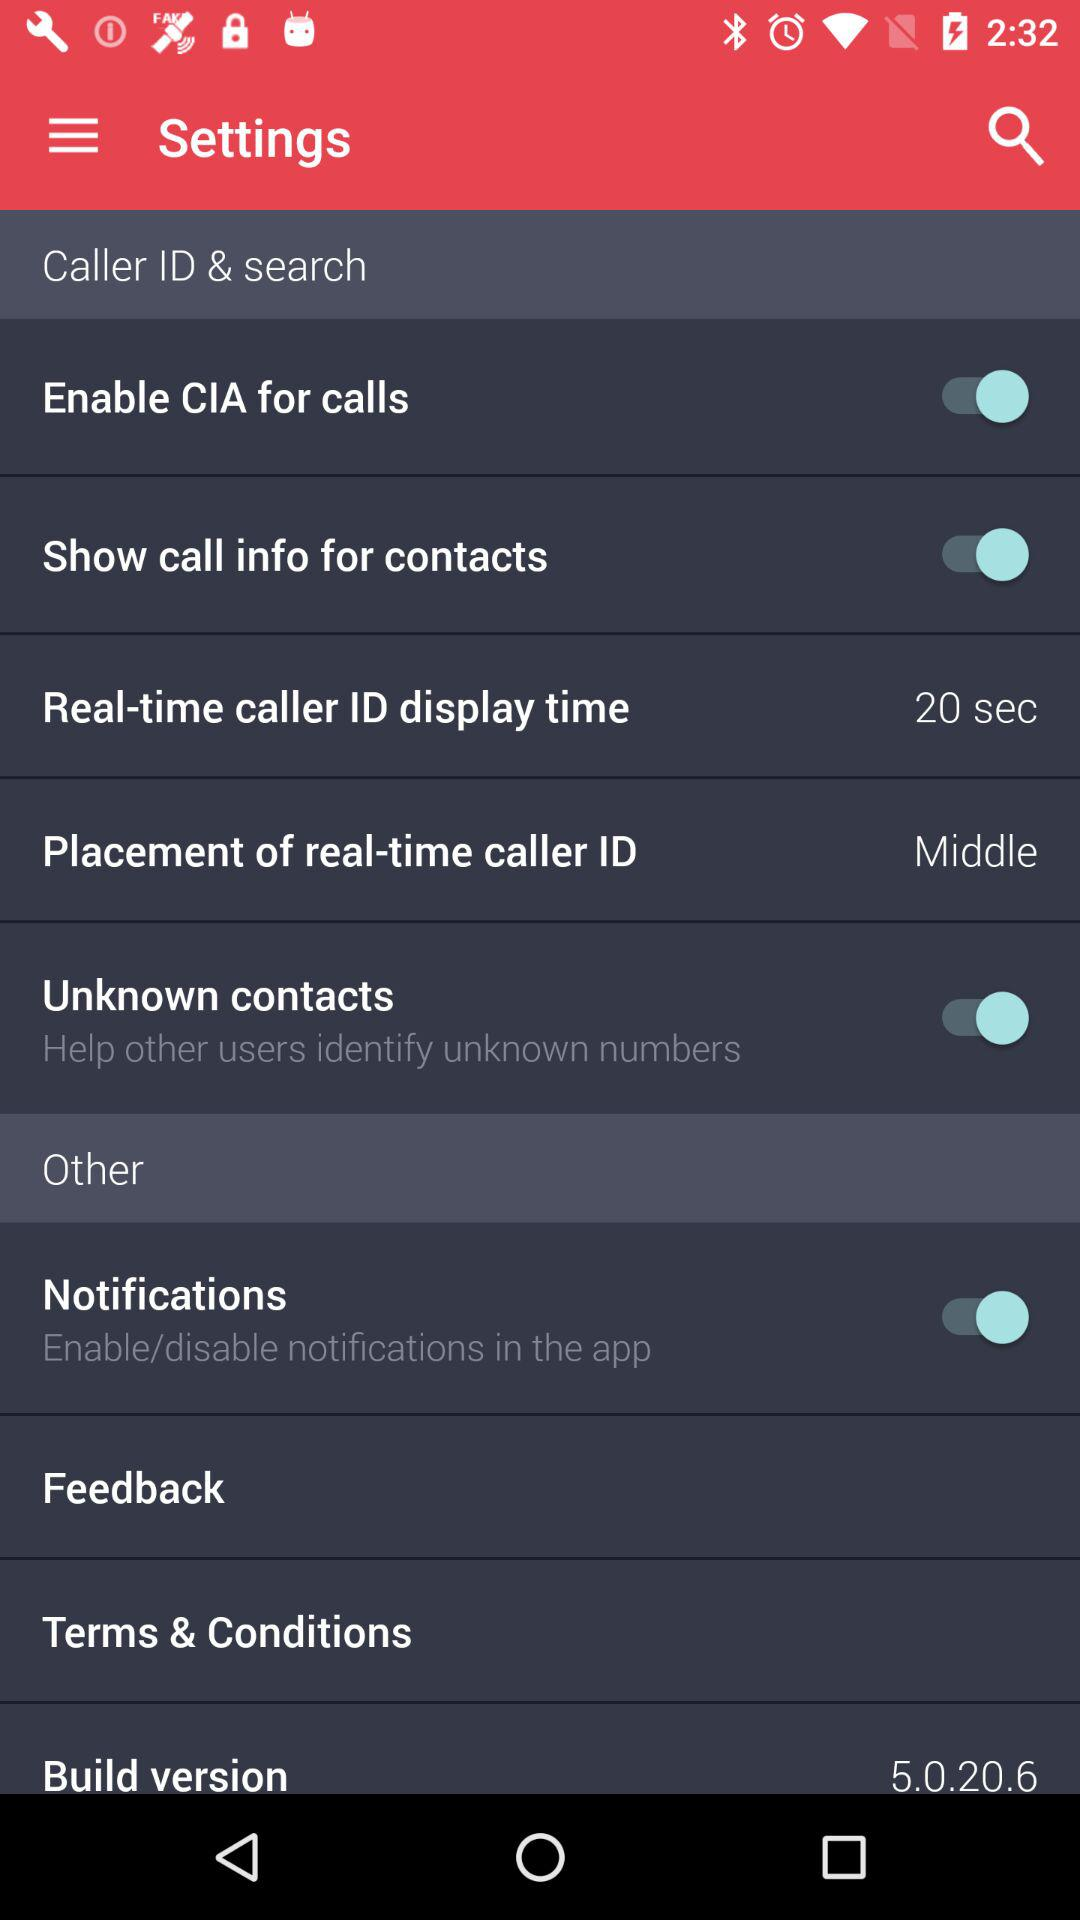What is the "Real-time caller ID display time"? The "Real-time caller ID display time" is 20 seconds. 